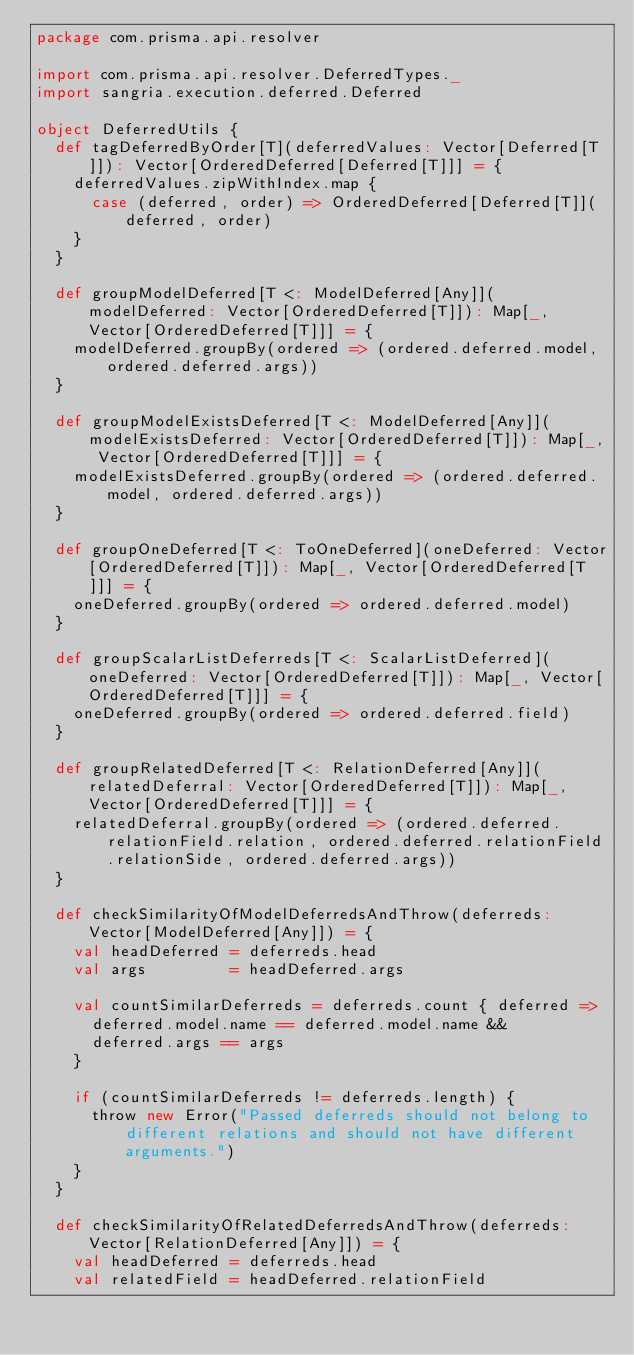Convert code to text. <code><loc_0><loc_0><loc_500><loc_500><_Scala_>package com.prisma.api.resolver

import com.prisma.api.resolver.DeferredTypes._
import sangria.execution.deferred.Deferred

object DeferredUtils {
  def tagDeferredByOrder[T](deferredValues: Vector[Deferred[T]]): Vector[OrderedDeferred[Deferred[T]]] = {
    deferredValues.zipWithIndex.map {
      case (deferred, order) => OrderedDeferred[Deferred[T]](deferred, order)
    }
  }

  def groupModelDeferred[T <: ModelDeferred[Any]](modelDeferred: Vector[OrderedDeferred[T]]): Map[_, Vector[OrderedDeferred[T]]] = {
    modelDeferred.groupBy(ordered => (ordered.deferred.model, ordered.deferred.args))
  }

  def groupModelExistsDeferred[T <: ModelDeferred[Any]](modelExistsDeferred: Vector[OrderedDeferred[T]]): Map[_, Vector[OrderedDeferred[T]]] = {
    modelExistsDeferred.groupBy(ordered => (ordered.deferred.model, ordered.deferred.args))
  }

  def groupOneDeferred[T <: ToOneDeferred](oneDeferred: Vector[OrderedDeferred[T]]): Map[_, Vector[OrderedDeferred[T]]] = {
    oneDeferred.groupBy(ordered => ordered.deferred.model)
  }

  def groupScalarListDeferreds[T <: ScalarListDeferred](oneDeferred: Vector[OrderedDeferred[T]]): Map[_, Vector[OrderedDeferred[T]]] = {
    oneDeferred.groupBy(ordered => ordered.deferred.field)
  }

  def groupRelatedDeferred[T <: RelationDeferred[Any]](relatedDeferral: Vector[OrderedDeferred[T]]): Map[_, Vector[OrderedDeferred[T]]] = {
    relatedDeferral.groupBy(ordered => (ordered.deferred.relationField.relation, ordered.deferred.relationField.relationSide, ordered.deferred.args))
  }

  def checkSimilarityOfModelDeferredsAndThrow(deferreds: Vector[ModelDeferred[Any]]) = {
    val headDeferred = deferreds.head
    val args         = headDeferred.args

    val countSimilarDeferreds = deferreds.count { deferred =>
      deferred.model.name == deferred.model.name &&
      deferred.args == args
    }

    if (countSimilarDeferreds != deferreds.length) {
      throw new Error("Passed deferreds should not belong to different relations and should not have different arguments.")
    }
  }

  def checkSimilarityOfRelatedDeferredsAndThrow(deferreds: Vector[RelationDeferred[Any]]) = {
    val headDeferred = deferreds.head
    val relatedField = headDeferred.relationField</code> 